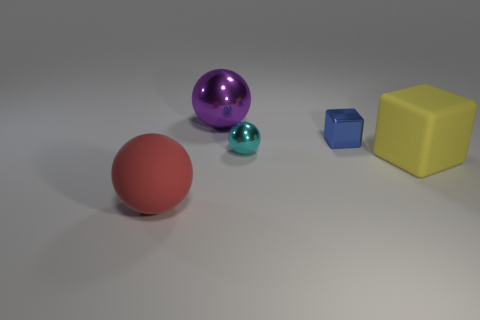Subtract all blue balls. Subtract all brown cubes. How many balls are left? 3 Add 4 large yellow objects. How many objects exist? 9 Subtract all balls. How many objects are left? 2 Subtract all small metallic things. Subtract all large balls. How many objects are left? 1 Add 5 blue shiny things. How many blue shiny things are left? 6 Add 5 shiny spheres. How many shiny spheres exist? 7 Subtract 1 purple spheres. How many objects are left? 4 